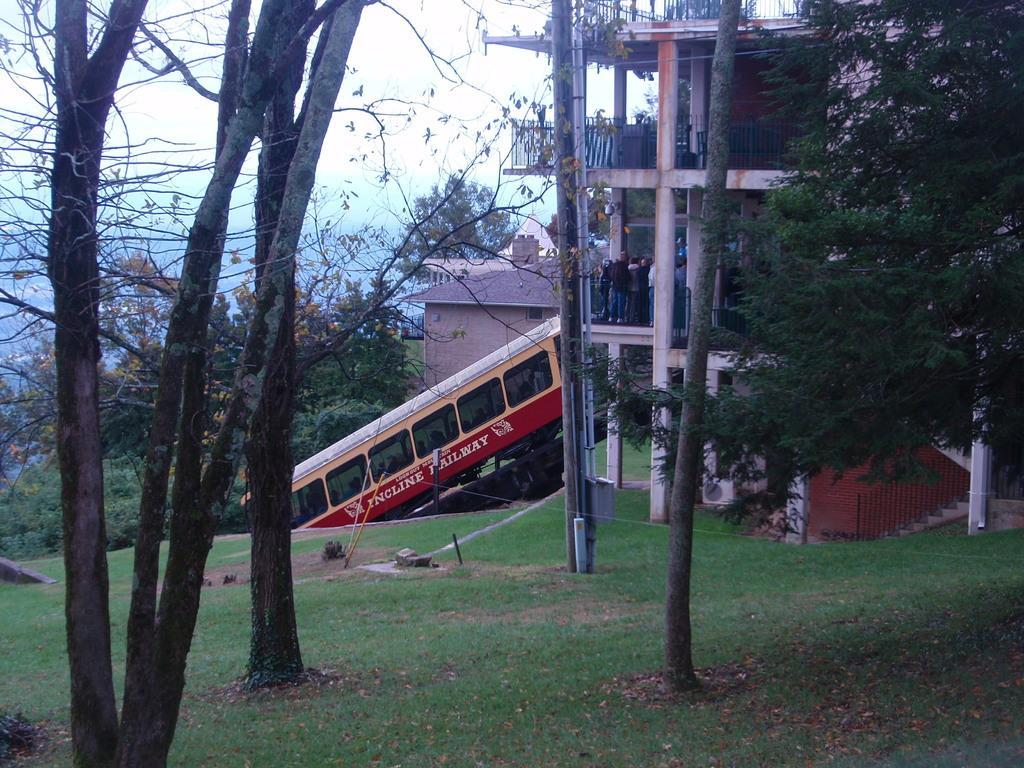Could you give a brief overview of what you see in this image? In this picture we can see a vehicle with some people inside it, trees, grass, buildings and in the background we can see the sky. 